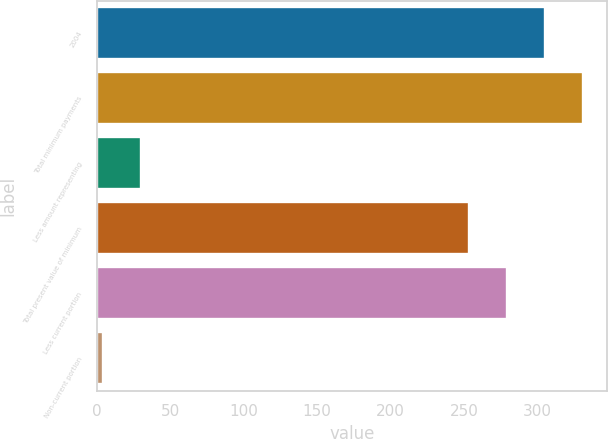Convert chart to OTSL. <chart><loc_0><loc_0><loc_500><loc_500><bar_chart><fcel>2004<fcel>Total minimum payments<fcel>Less amount representing<fcel>Total present value of minimum<fcel>Less current portion<fcel>Non-current portion<nl><fcel>304.68<fcel>330.52<fcel>30.42<fcel>253<fcel>278.84<fcel>4.58<nl></chart> 